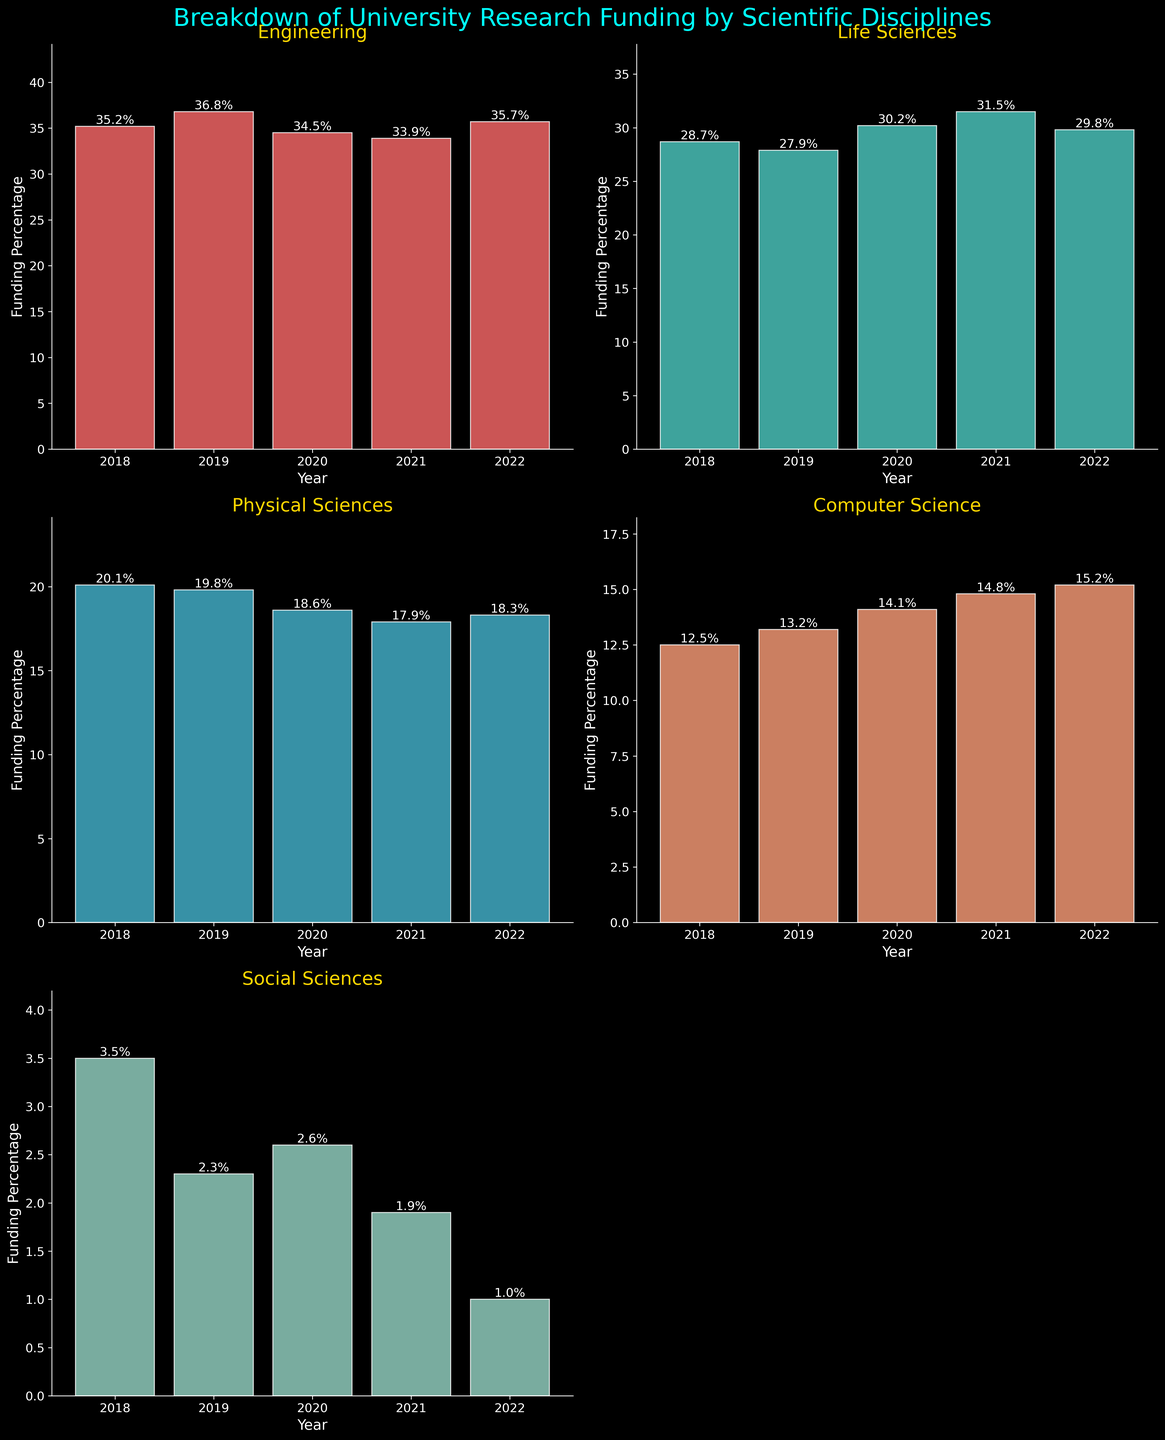Which discipline received the highest percentage of research funding in 2020? The 2020 funding percentages for each discipline are displayed on their respective bars. Life Sciences received the highest funding percentage in 2020 at 30.2%.
Answer: Life Sciences What was the funding percentage for Computer Science in 2018? The 2018 bar for Computer Science shows a height of 12.5%, according to the figure.
Answer: 12.5% How did the funding percentage for Social Sciences change from 2019 to 2022? The percentage for Social Sciences decreased from 2.3% in 2019 to 1.0% in 2022. This is a decline of 1.3%.
Answer: Decreased by 1.3% Which discipline had the smallest change in funding percentage from 2018 to 2022? By observing the bars from 2018 to 2022 across all disciplines, Physical Sciences had the smallest change, decreasing from 20.1% to 18.3%, a change of 1.8%.
Answer: Physical Sciences Which disciplines saw an increase in funding percentage from 2019 to 2021? From 2019 to 2021, Life Sciences increased from 27.9% to 31.5%, and Computer Science increased from 13.2% to 14.8%.
Answer: Life Sciences and Computer Science What is the average funding percentage for Engineering across all years? Sum the percentages for Engineering across all years (35.2, 36.8, 34.5, 33.9, 35.7) and divide by the number of years (5). The average is (35.2 + 36.8 + 34.5 + 33.9 + 35.7) / 5 = 35.22%.
Answer: 35.22% In which year did Physical Sciences receive the least funding and what was the percentage? The 2021 bar for Physical Sciences shows the least funding at 17.9% compared to other years.
Answer: 2021, 17.9% Is the funding trend for Social Sciences consistently decreasing over the years? Observing the bars for Social Sciences from 2018 to 2022, the percentages continuously decrease from 3.5% to 1.0%.
Answer: Yes How does the funding for Computer Science in 2022 compare to that in 2018? In 2018, Computer Science had a funding percentage of 12.5%, while in 2022, it was 15.2%. The funding increased by 2.7%.
Answer: Increased by 2.7% What is the total percentage of funding allocated to the Life Sciences and Social Sciences in 2020? In 2020, Life Sciences received 30.2% and Social Sciences received 2.6%. Adding these gives 30.2% + 2.6% = 32.8%.
Answer: 32.8% 